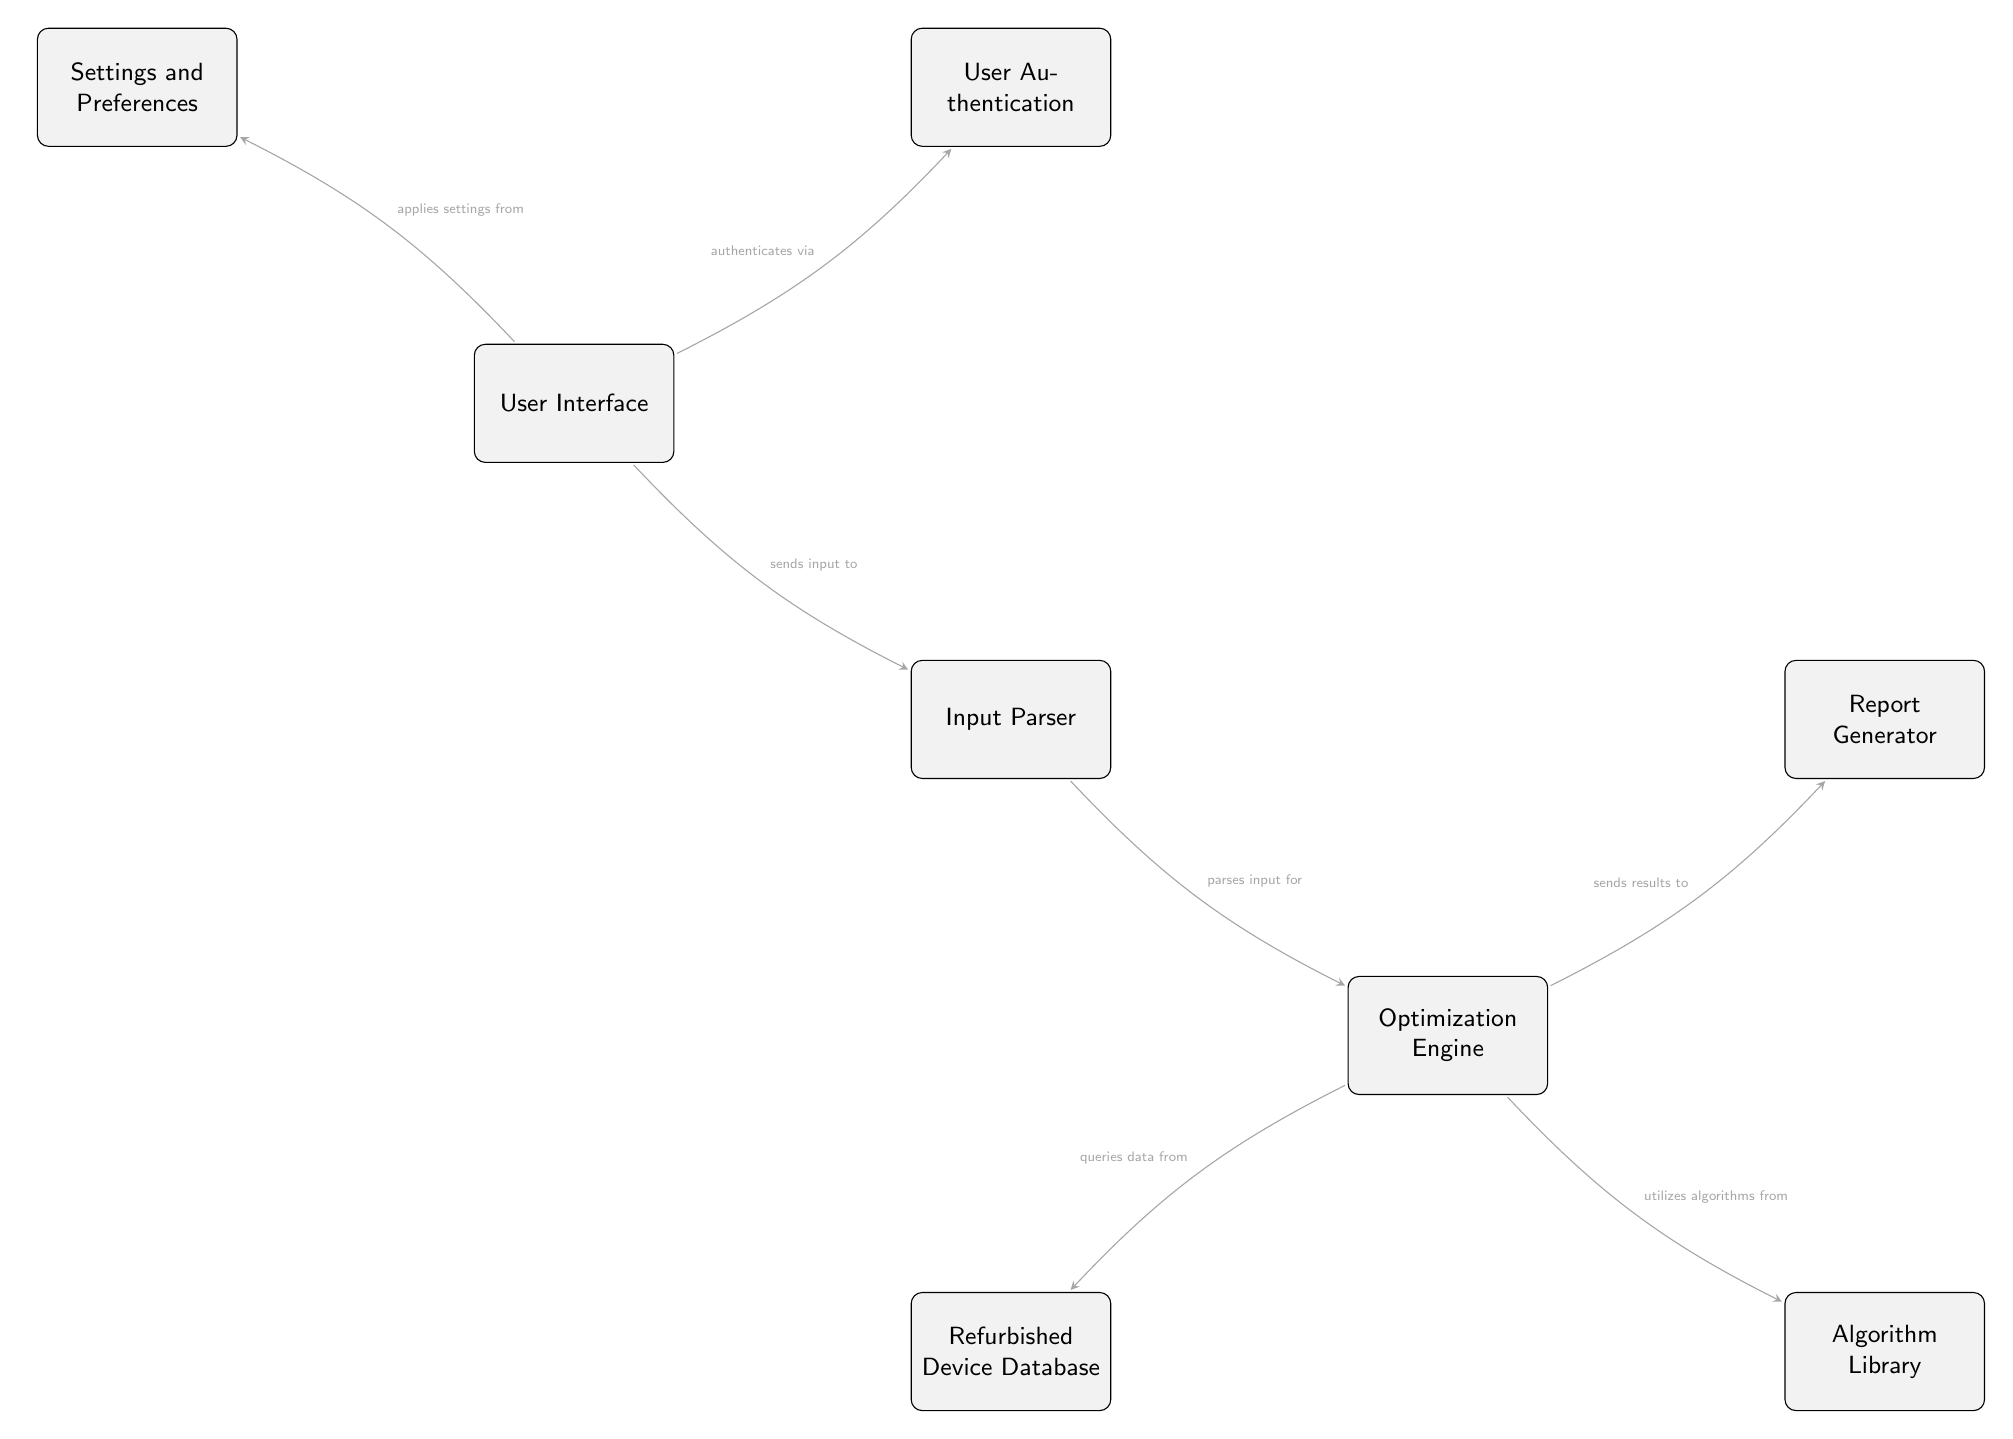What is the top node in the diagram? The top node in the diagram is the User Interface. It is visually positioned at the highest point of the diagram, indicating it is the entry point for user interaction.
Answer: User Interface How many nodes are in the diagram? The diagram contains 8 nodes, which include the User Interface, Input Parser, Optimization Engine, Refurbished Device Database, Algorithm Library, Report Generator, Settings and Preferences, and User Authentication. By counting these distinct rectangles in the diagram, we confirm the total.
Answer: 8 Which node does the Input Parser send data to? The Input Parser sends data to the Optimization Engine, as indicated by the directed arrow connecting these two nodes. The diagram specifies this flow of information.
Answer: Optimization Engine What does the Optimization Engine utilize from the Algorithm Library? The Optimization Engine utilizes algorithms, as indicated by the arrow labeled "utilizes algorithms from" pointing towards the Algorithm Library. This indicates the type of resource the Optimization Engine takes from that node.
Answer: Algorithms What is the relationship between the User Interface and User Authentication? The relationship is that the User Interface authenticates via User Authentication. The arrow points from the User Interface to User Authentication, indicating a direct dependence for user verification.
Answer: Authenticates via What data does the Optimization Engine query from the Refurbished Device Database? The Optimization Engine queries data, as stated in the diagram with the text "queries data from" pointing towards the Refurbished Device Database. This shows that it retrieves necessary data for optimizations from this source.
Answer: Data Which node is responsible for generating reports? The Report Generator is responsible for generating reports. The directed arrow indicates the flow of information from the Optimization Engine to this node, denoting its function in the context of the diagram.
Answer: Report Generator How does the User Interface apply settings? The User Interface applies settings from Settings and Preferences, as shown by the arrow directing from the User Interface to this particular node. This implies a flow of configuration data to the User Interface.
Answer: Applies settings from What is the main function of the Optimization Engine in relation to other nodes? The main function of the Optimization Engine is to process input received from the Input Parser, query data from the Refurbished Device Database, and utilize algorithms from the Algorithm Library, before sending results to the Report Generator. This summarizes its role in optimizing processes.
Answer: Optimization 